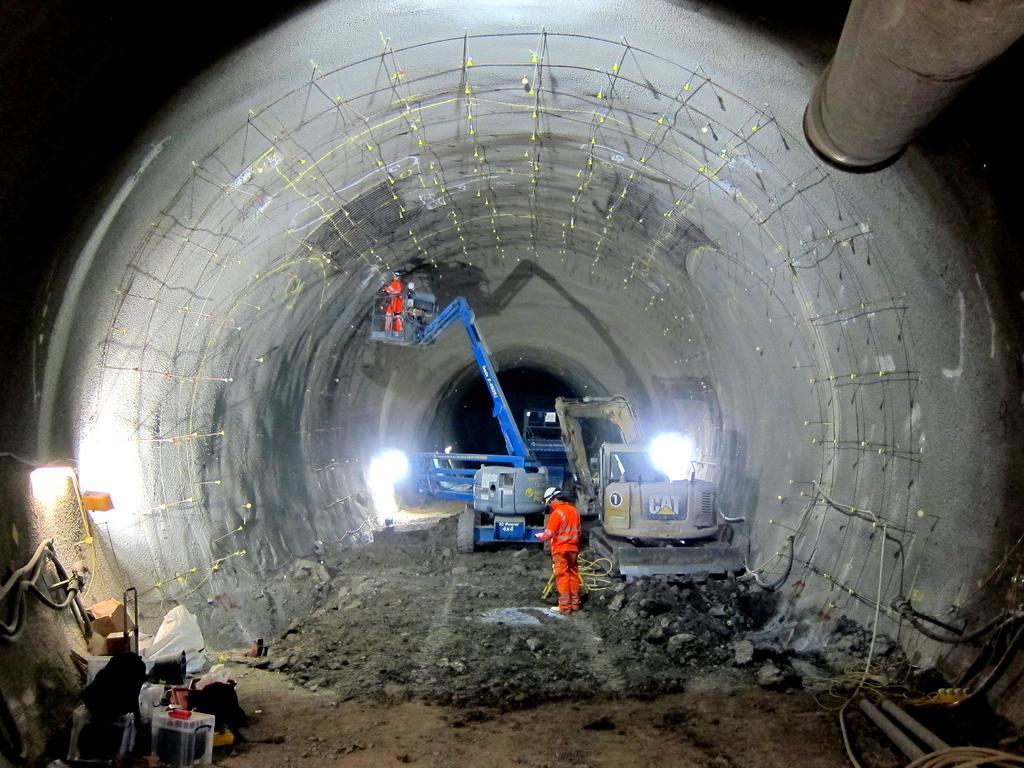Can you describe this image briefly? In this image, It looks like a tunnel, which is under construction. I can see a person standing. I think these are the cranes. Here is another person standing on the crane. At the bottom of the image, I can see few objects, which are kept on the ground. At the top right corner of the image, It looks like a pipe. The background looks dark. 